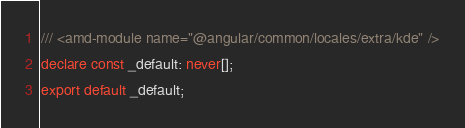Convert code to text. <code><loc_0><loc_0><loc_500><loc_500><_TypeScript_>/// <amd-module name="@angular/common/locales/extra/kde" />
declare const _default: never[];
export default _default;
</code> 